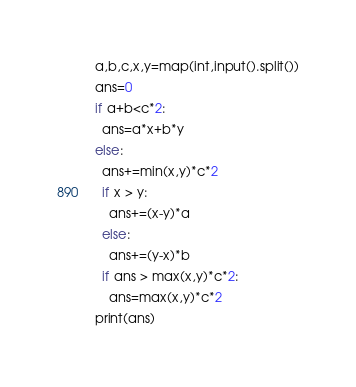Convert code to text. <code><loc_0><loc_0><loc_500><loc_500><_Python_>a,b,c,x,y=map(int,input().split())
ans=0
if a+b<c*2:
  ans=a*x+b*y
else:
  ans+=min(x,y)*c*2
  if x > y:
    ans+=(x-y)*a
  else:
    ans+=(y-x)*b
  if ans > max(x,y)*c*2:
    ans=max(x,y)*c*2
print(ans)</code> 